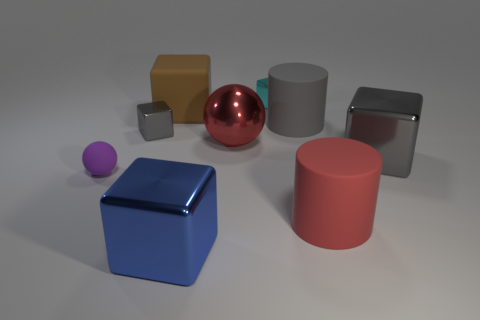Subtract all gray blocks. How many blocks are left? 3 Subtract 2 blocks. How many blocks are left? 3 Subtract all big gray blocks. How many blocks are left? 4 Subtract all red blocks. Subtract all blue balls. How many blocks are left? 5 Add 1 green spheres. How many objects exist? 10 Subtract all balls. How many objects are left? 7 Subtract 0 blue balls. How many objects are left? 9 Subtract all brown cylinders. Subtract all small balls. How many objects are left? 8 Add 5 big blue things. How many big blue things are left? 6 Add 7 green rubber blocks. How many green rubber blocks exist? 7 